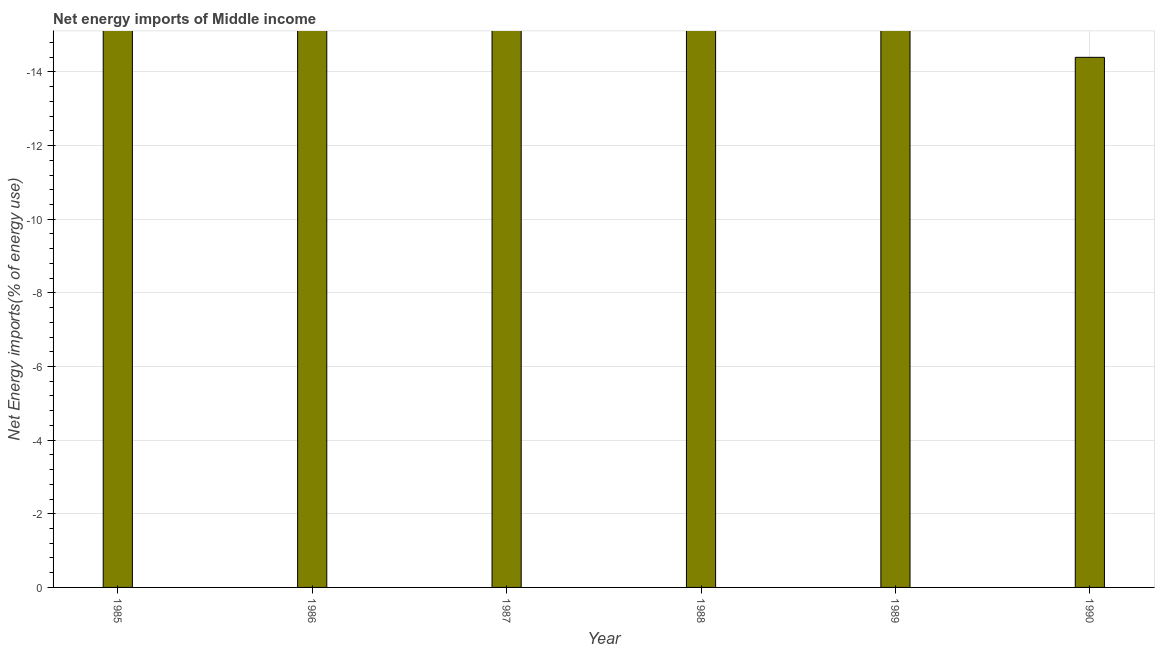Does the graph contain any zero values?
Provide a short and direct response. Yes. What is the title of the graph?
Your answer should be compact. Net energy imports of Middle income. What is the label or title of the Y-axis?
Keep it short and to the point. Net Energy imports(% of energy use). What is the energy imports in 1985?
Your response must be concise. 0. What is the average energy imports per year?
Offer a very short reply. 0. What is the median energy imports?
Provide a succinct answer. 0. In how many years, is the energy imports greater than the average energy imports taken over all years?
Make the answer very short. 0. How many bars are there?
Provide a short and direct response. 0. Are the values on the major ticks of Y-axis written in scientific E-notation?
Your answer should be very brief. No. What is the Net Energy imports(% of energy use) of 1987?
Provide a short and direct response. 0. What is the Net Energy imports(% of energy use) of 1988?
Make the answer very short. 0. What is the Net Energy imports(% of energy use) of 1989?
Keep it short and to the point. 0. 